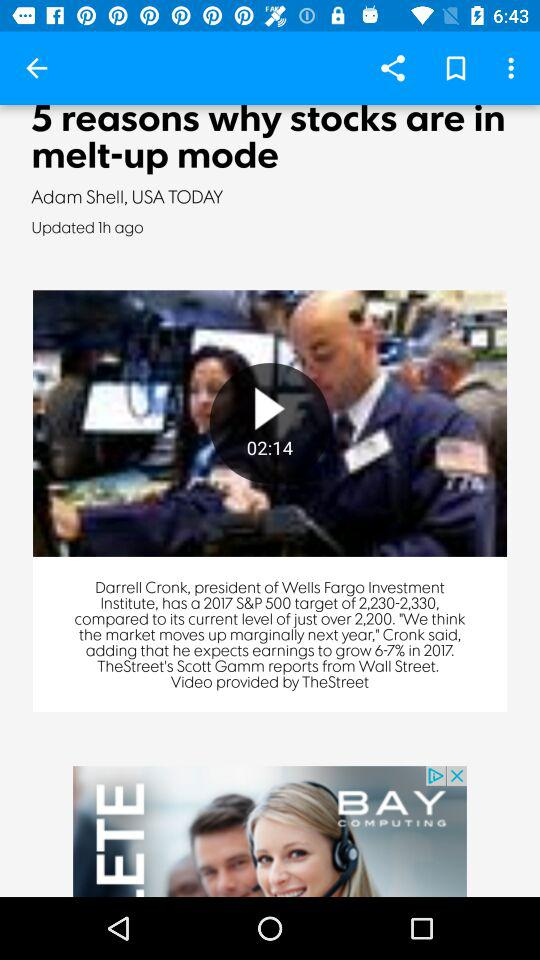What are the news headlines? The news headline is "5 reasons why stocks are in melt-up mode". 